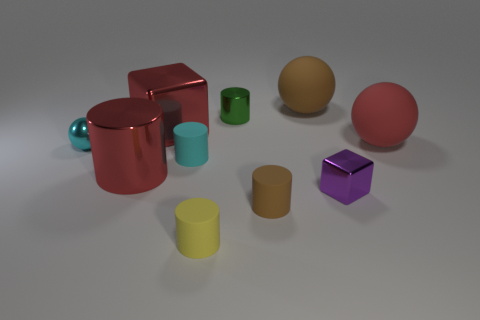Is the material of the tiny green cylinder the same as the yellow cylinder?
Give a very brief answer. No. How many cylinders are tiny red things or tiny cyan rubber things?
Keep it short and to the point. 1. There is a shiny object that is to the right of the rubber thing that is behind the large cube; what color is it?
Offer a terse response. Purple. There is a matte ball that is the same color as the large metallic cube; what size is it?
Give a very brief answer. Large. There is a matte thing right of the tiny purple thing on the right side of the green metallic cylinder; what number of matte objects are in front of it?
Make the answer very short. 3. Does the large red metallic thing that is behind the cyan metallic thing have the same shape as the red object right of the yellow object?
Offer a very short reply. No. How many objects are big metallic cylinders or small cubes?
Ensure brevity in your answer.  2. What material is the large red thing that is on the left side of the block behind the small ball?
Ensure brevity in your answer.  Metal. Is there a large cube that has the same color as the metallic sphere?
Your answer should be compact. No. What is the color of the ball that is the same size as the green shiny thing?
Keep it short and to the point. Cyan. 